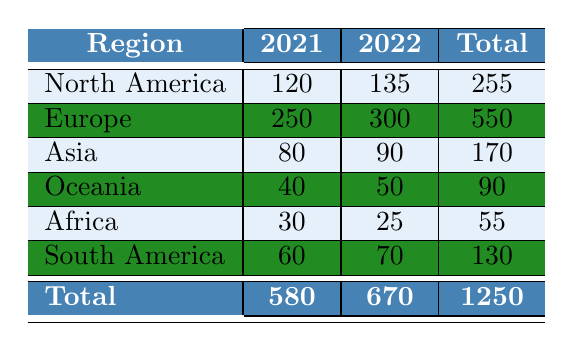What is the total number of art forgery incidents in 2021? The total number of incidents in 2021 can be found by summing the values of the "2021" column. The values are 120 (North America) + 250 (Europe) + 80 (Asia) + 40 (Oceania) + 30 (Africa) + 60 (South America) = 580.
Answer: 580 Which region had the highest number of art forgery incidents in 2022? In the "2022" column, the number of incidents for each region is as follows: North America (135), Europe (300), Asia (90), Oceania (50), Africa (25), South America (70). The highest value is 300, which corresponds to Europe.
Answer: Europe What is the difference in the number of incidents between Asia in 2022 and Asia in 2021? To find the difference, we calculate the values for Asia: 90 (2022) - 80 (2021) = 10.
Answer: 10 Are there more incidents in North America than in Africa in 2021? In 2021, North America had 120 incidents while Africa had 30 incidents. Since 120 is greater than 30, the answer is yes.
Answer: Yes What is the average number of art forgery incidents in Oceania over the two years? To find the average, we sum the incidents in Oceania for 2021 (40) and 2022 (50) and divide by 2: (40 + 50) / 2 = 45.
Answer: 45 What is the total number of art forgery incidents across all regions for both years? To find the total, we sum all the incidents in the "Total" column: 255 (North America) + 550 (Europe) + 170 (Asia) + 90 (Oceania) + 55 (Africa) + 130 (South America) = 1250.
Answer: 1250 Did the number of incidents in South America increase from 2021 to 2022? In South America, the incident counts are 60 (2021) and 70 (2022). Since 70 is greater than 60, the answer is yes.
Answer: Yes What percentage of the total incidents in 2021 do the incidents in Europe represent? The total incidents in 2021 are 580, and the incidents in Europe are 250. To find the percentage, calculate (250 / 580) * 100 = approximately 43.1%.
Answer: 43.1% Which region had the least number of incidents in 2022? By reviewing the "2022" column, the values are: North America (135), Europe (300), Asia (90), Oceania (50), Africa (25), South America (70). The least is 25, which corresponds to Africa.
Answer: Africa 